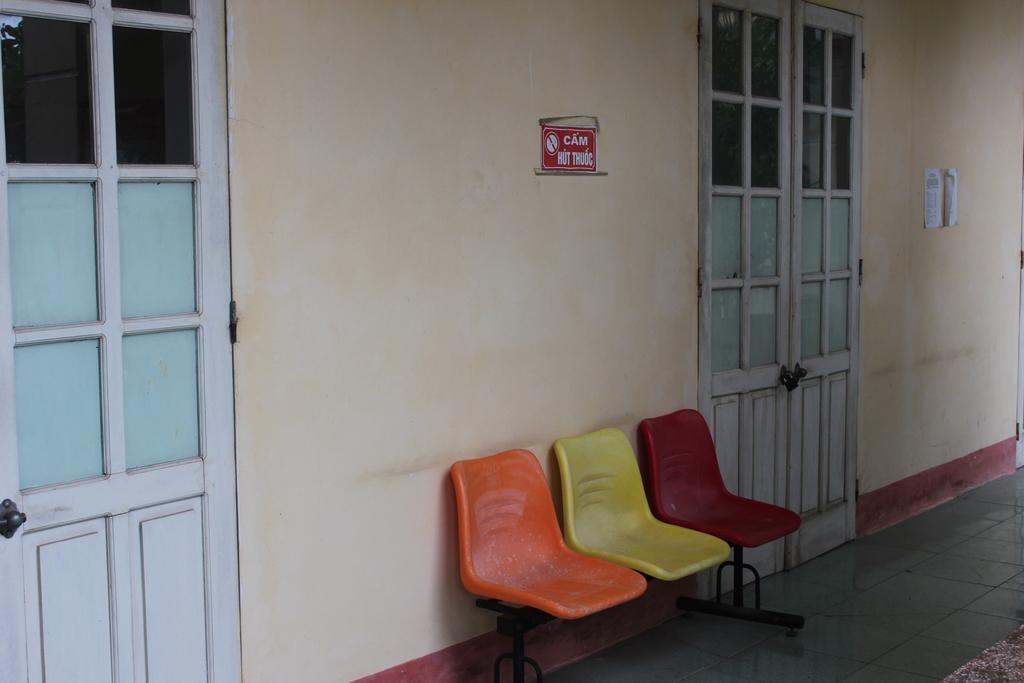What type of furniture is present in the image? There are chairs in the image. Where are the chairs located? The chairs are on a surface in the image. What architectural features can be seen in the image? There are doors, a floor, and a wall in the image. How much wealth is represented by the chain on the wall in the image? There is no chain present in the image, and therefore no wealth can be associated with it. 